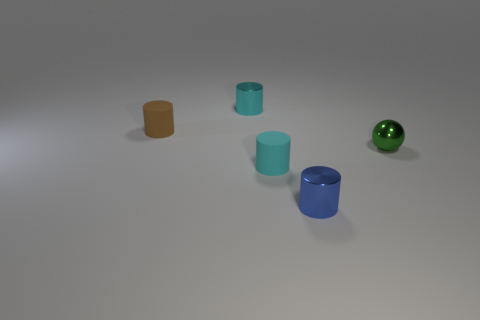Is there any indication of what time of day it could be in this set up? Since the image appears to be a staged composition rather than a natural setting, it does not provide any specific clues regarding the time of day. 